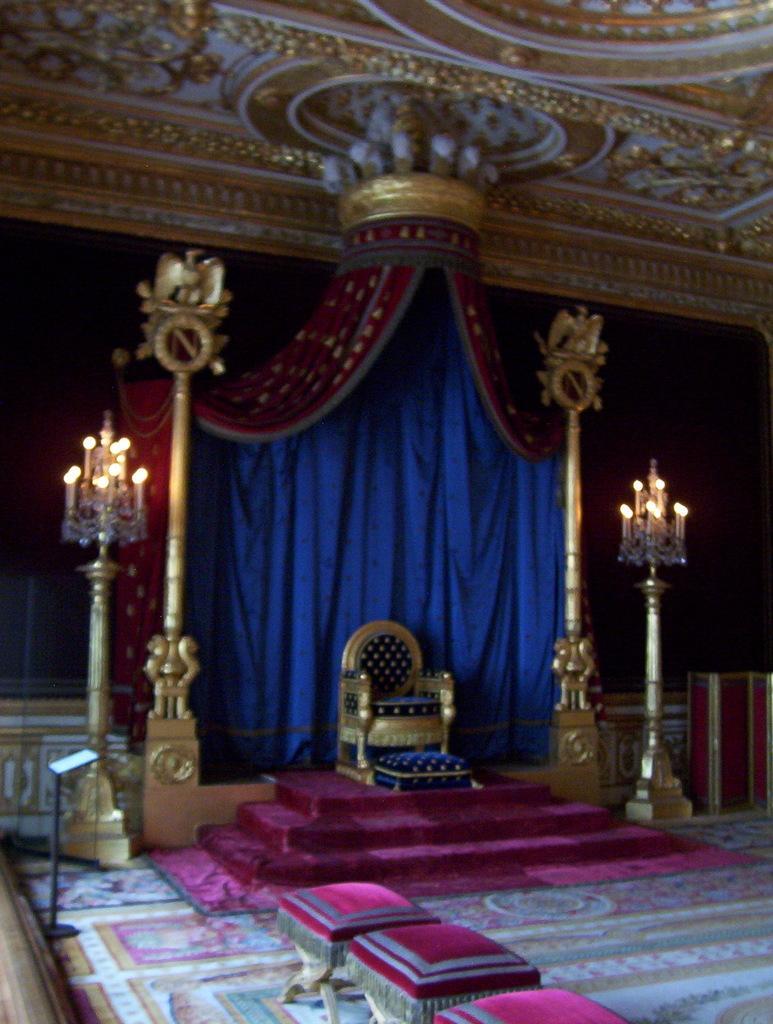Could you give a brief overview of what you see in this image? In this picture there is a chair and there are pink color table and pink color staircase and two candle stands and on stands there are candles and blue color curtain and colorful roof visible in the middle. 